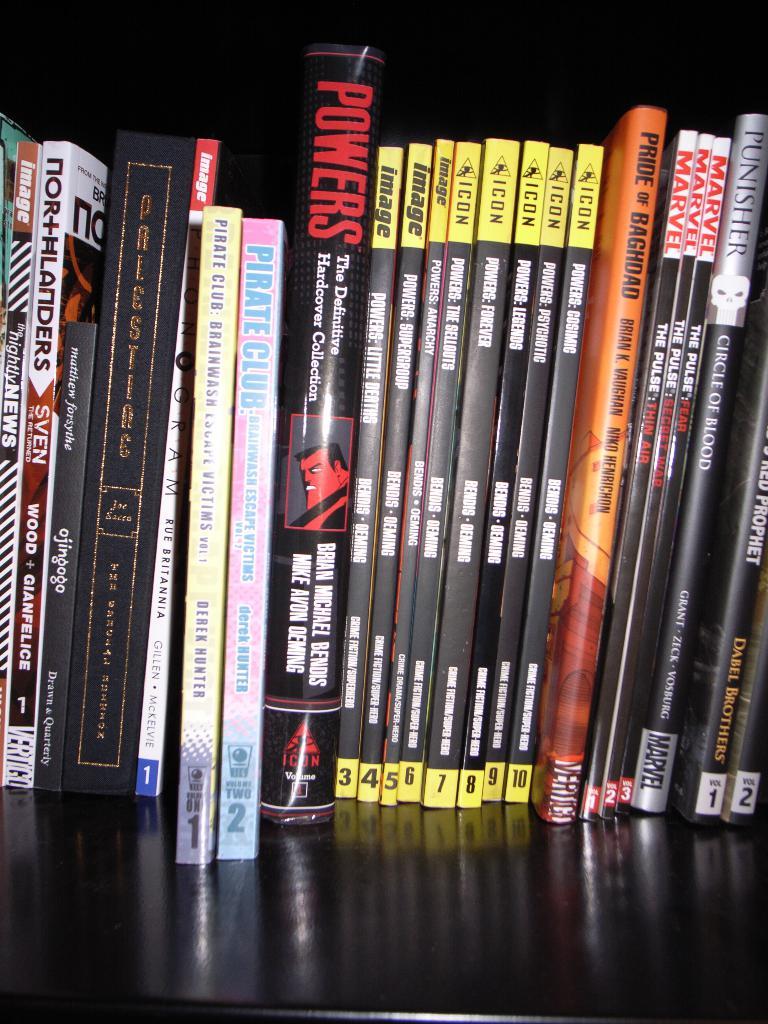What is the title of the pink book?
Keep it short and to the point. Pirate club. 